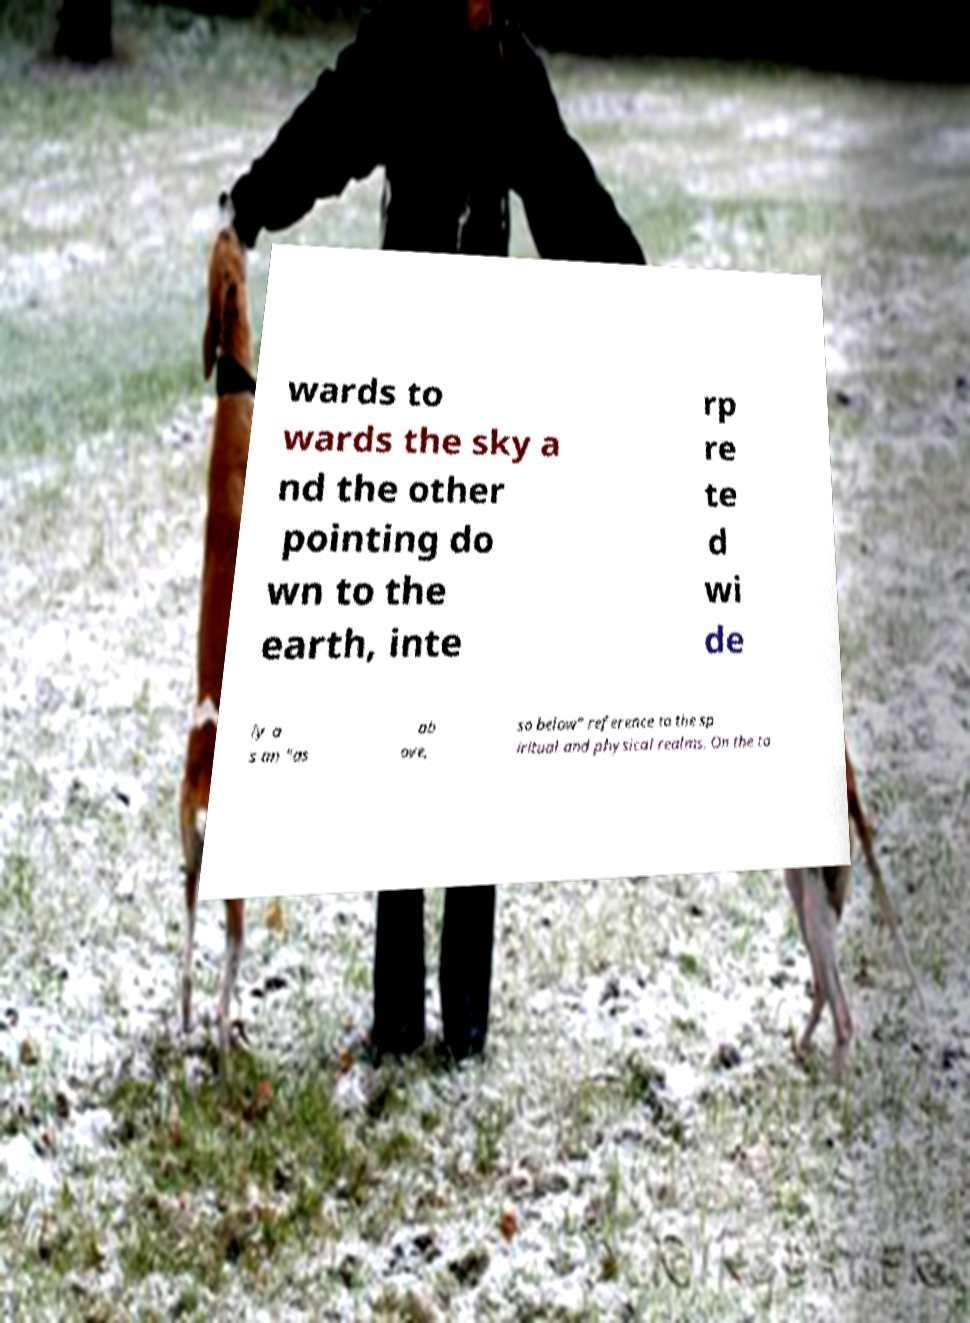There's text embedded in this image that I need extracted. Can you transcribe it verbatim? wards to wards the sky a nd the other pointing do wn to the earth, inte rp re te d wi de ly a s an "as ab ove, so below" reference to the sp iritual and physical realms. On the ta 